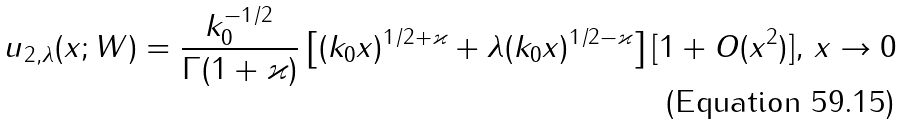Convert formula to latex. <formula><loc_0><loc_0><loc_500><loc_500>u _ { 2 , \lambda } ( x ; W ) = \frac { k _ { 0 } ^ { - 1 / 2 } } { \Gamma ( 1 + \varkappa ) } \left [ ( k _ { 0 } x ) ^ { 1 / 2 + \varkappa } + \lambda ( k _ { 0 } x ) ^ { 1 / 2 - \varkappa } \right ] [ 1 + O ( x ^ { 2 } ) ] , \, x \rightarrow 0</formula> 